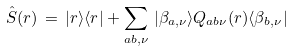Convert formula to latex. <formula><loc_0><loc_0><loc_500><loc_500>\hat { S } ( { r } ) \, = \, | { r } \rangle \langle { r } | + \sum _ { a b , \nu } \, | \beta _ { a , \nu } \rangle Q _ { a b \nu } ( { r } ) \langle \beta _ { b , \nu } |</formula> 